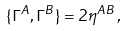Convert formula to latex. <formula><loc_0><loc_0><loc_500><loc_500>\{ \Gamma ^ { A } , \Gamma ^ { B } \} = 2 \eta ^ { A B } \, ,</formula> 